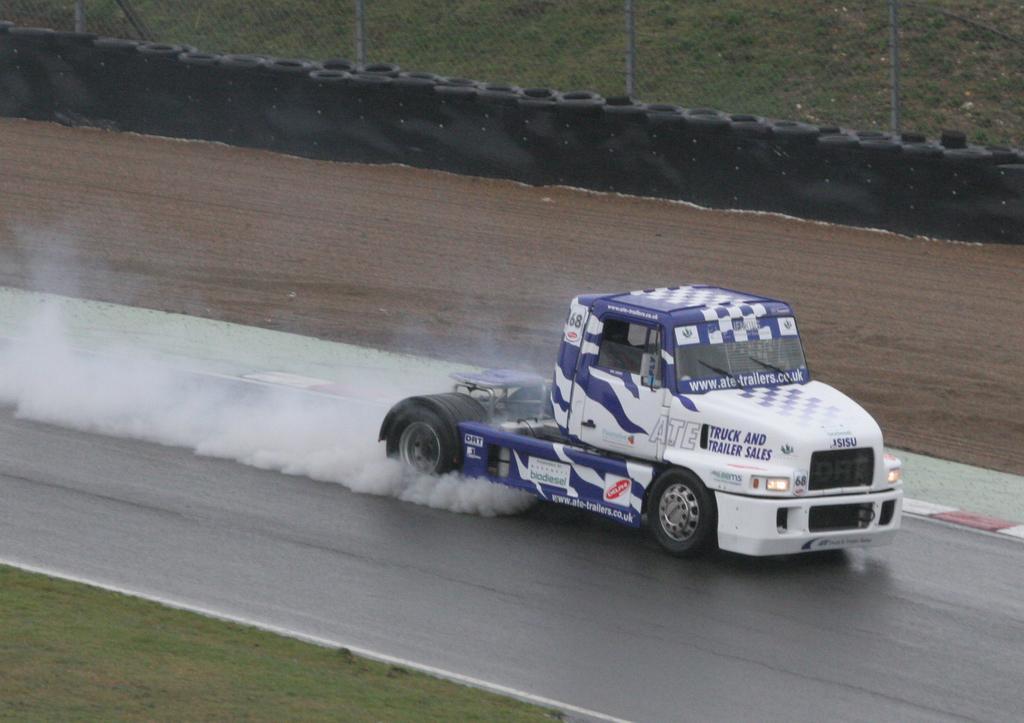How would you summarize this image in a sentence or two? In this image we can see a trailer truck on the road. At the bottom of the image there is the grass. In the background of the image there is a fence, wall, road and other objects. 